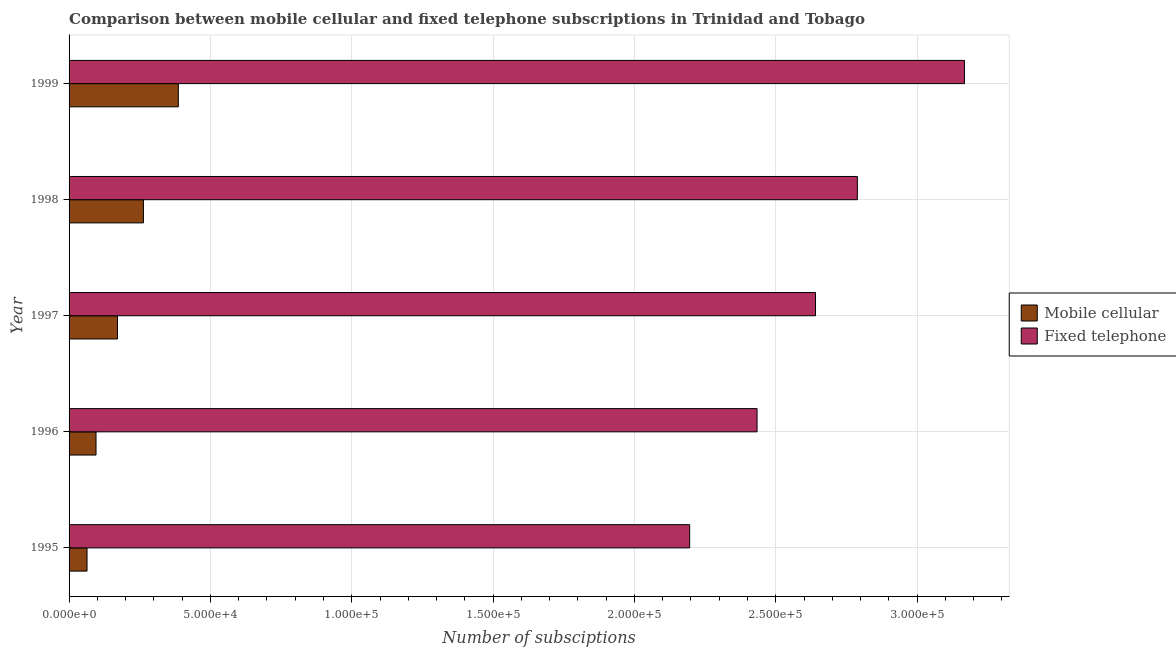How many different coloured bars are there?
Give a very brief answer. 2. How many groups of bars are there?
Your answer should be very brief. 5. How many bars are there on the 5th tick from the top?
Give a very brief answer. 2. How many bars are there on the 1st tick from the bottom?
Your answer should be compact. 2. What is the label of the 5th group of bars from the top?
Provide a short and direct response. 1995. What is the number of fixed telephone subscriptions in 1996?
Provide a succinct answer. 2.43e+05. Across all years, what is the maximum number of fixed telephone subscriptions?
Your response must be concise. 3.17e+05. Across all years, what is the minimum number of fixed telephone subscriptions?
Your answer should be compact. 2.20e+05. In which year was the number of fixed telephone subscriptions maximum?
Offer a terse response. 1999. In which year was the number of mobile cellular subscriptions minimum?
Keep it short and to the point. 1995. What is the total number of fixed telephone subscriptions in the graph?
Offer a very short reply. 1.32e+06. What is the difference between the number of fixed telephone subscriptions in 1996 and that in 1998?
Give a very brief answer. -3.55e+04. What is the difference between the number of mobile cellular subscriptions in 1995 and the number of fixed telephone subscriptions in 1996?
Ensure brevity in your answer.  -2.37e+05. What is the average number of mobile cellular subscriptions per year?
Ensure brevity in your answer.  1.96e+04. In the year 1997, what is the difference between the number of mobile cellular subscriptions and number of fixed telephone subscriptions?
Give a very brief answer. -2.47e+05. What is the ratio of the number of fixed telephone subscriptions in 1996 to that in 1999?
Your response must be concise. 0.77. Is the difference between the number of mobile cellular subscriptions in 1995 and 1998 greater than the difference between the number of fixed telephone subscriptions in 1995 and 1998?
Offer a very short reply. Yes. What is the difference between the highest and the second highest number of mobile cellular subscriptions?
Keep it short and to the point. 1.24e+04. What is the difference between the highest and the lowest number of mobile cellular subscriptions?
Offer a terse response. 3.23e+04. What does the 2nd bar from the top in 1995 represents?
Your response must be concise. Mobile cellular. What does the 2nd bar from the bottom in 1997 represents?
Your answer should be very brief. Fixed telephone. How many years are there in the graph?
Ensure brevity in your answer.  5. What is the difference between two consecutive major ticks on the X-axis?
Keep it short and to the point. 5.00e+04. How many legend labels are there?
Your answer should be compact. 2. How are the legend labels stacked?
Offer a terse response. Vertical. What is the title of the graph?
Provide a succinct answer. Comparison between mobile cellular and fixed telephone subscriptions in Trinidad and Tobago. What is the label or title of the X-axis?
Make the answer very short. Number of subsciptions. What is the Number of subsciptions of Mobile cellular in 1995?
Provide a succinct answer. 6353. What is the Number of subsciptions in Fixed telephone in 1995?
Offer a terse response. 2.20e+05. What is the Number of subsciptions in Mobile cellular in 1996?
Keep it short and to the point. 9534. What is the Number of subsciptions of Fixed telephone in 1996?
Provide a short and direct response. 2.43e+05. What is the Number of subsciptions of Mobile cellular in 1997?
Your answer should be very brief. 1.71e+04. What is the Number of subsciptions of Fixed telephone in 1997?
Provide a succinct answer. 2.64e+05. What is the Number of subsciptions in Mobile cellular in 1998?
Ensure brevity in your answer.  2.63e+04. What is the Number of subsciptions of Fixed telephone in 1998?
Offer a terse response. 2.79e+05. What is the Number of subsciptions of Mobile cellular in 1999?
Offer a terse response. 3.87e+04. What is the Number of subsciptions of Fixed telephone in 1999?
Ensure brevity in your answer.  3.17e+05. Across all years, what is the maximum Number of subsciptions of Mobile cellular?
Offer a very short reply. 3.87e+04. Across all years, what is the maximum Number of subsciptions of Fixed telephone?
Provide a succinct answer. 3.17e+05. Across all years, what is the minimum Number of subsciptions in Mobile cellular?
Your response must be concise. 6353. Across all years, what is the minimum Number of subsciptions of Fixed telephone?
Keep it short and to the point. 2.20e+05. What is the total Number of subsciptions in Mobile cellular in the graph?
Your response must be concise. 9.80e+04. What is the total Number of subsciptions of Fixed telephone in the graph?
Provide a succinct answer. 1.32e+06. What is the difference between the Number of subsciptions in Mobile cellular in 1995 and that in 1996?
Ensure brevity in your answer.  -3181. What is the difference between the Number of subsciptions in Fixed telephone in 1995 and that in 1996?
Your answer should be compact. -2.38e+04. What is the difference between the Number of subsciptions of Mobile cellular in 1995 and that in 1997?
Provide a short and direct response. -1.08e+04. What is the difference between the Number of subsciptions of Fixed telephone in 1995 and that in 1997?
Offer a terse response. -4.45e+04. What is the difference between the Number of subsciptions of Mobile cellular in 1995 and that in 1998?
Offer a terse response. -2.00e+04. What is the difference between the Number of subsciptions in Fixed telephone in 1995 and that in 1998?
Give a very brief answer. -5.93e+04. What is the difference between the Number of subsciptions in Mobile cellular in 1995 and that in 1999?
Give a very brief answer. -3.23e+04. What is the difference between the Number of subsciptions in Fixed telephone in 1995 and that in 1999?
Your response must be concise. -9.72e+04. What is the difference between the Number of subsciptions in Mobile cellular in 1996 and that in 1997?
Your response must be concise. -7606. What is the difference between the Number of subsciptions in Fixed telephone in 1996 and that in 1997?
Give a very brief answer. -2.07e+04. What is the difference between the Number of subsciptions in Mobile cellular in 1996 and that in 1998?
Offer a terse response. -1.68e+04. What is the difference between the Number of subsciptions of Fixed telephone in 1996 and that in 1998?
Provide a short and direct response. -3.55e+04. What is the difference between the Number of subsciptions in Mobile cellular in 1996 and that in 1999?
Offer a very short reply. -2.91e+04. What is the difference between the Number of subsciptions in Fixed telephone in 1996 and that in 1999?
Provide a succinct answer. -7.34e+04. What is the difference between the Number of subsciptions in Mobile cellular in 1997 and that in 1998?
Your answer should be compact. -9167. What is the difference between the Number of subsciptions in Fixed telephone in 1997 and that in 1998?
Provide a short and direct response. -1.48e+04. What is the difference between the Number of subsciptions of Mobile cellular in 1997 and that in 1999?
Offer a very short reply. -2.15e+04. What is the difference between the Number of subsciptions in Fixed telephone in 1997 and that in 1999?
Give a very brief answer. -5.27e+04. What is the difference between the Number of subsciptions in Mobile cellular in 1998 and that in 1999?
Offer a very short reply. -1.24e+04. What is the difference between the Number of subsciptions of Fixed telephone in 1998 and that in 1999?
Ensure brevity in your answer.  -3.79e+04. What is the difference between the Number of subsciptions in Mobile cellular in 1995 and the Number of subsciptions in Fixed telephone in 1996?
Make the answer very short. -2.37e+05. What is the difference between the Number of subsciptions of Mobile cellular in 1995 and the Number of subsciptions of Fixed telephone in 1997?
Offer a terse response. -2.58e+05. What is the difference between the Number of subsciptions in Mobile cellular in 1995 and the Number of subsciptions in Fixed telephone in 1998?
Give a very brief answer. -2.73e+05. What is the difference between the Number of subsciptions in Mobile cellular in 1995 and the Number of subsciptions in Fixed telephone in 1999?
Offer a terse response. -3.10e+05. What is the difference between the Number of subsciptions in Mobile cellular in 1996 and the Number of subsciptions in Fixed telephone in 1997?
Offer a very short reply. -2.55e+05. What is the difference between the Number of subsciptions in Mobile cellular in 1996 and the Number of subsciptions in Fixed telephone in 1998?
Offer a very short reply. -2.69e+05. What is the difference between the Number of subsciptions in Mobile cellular in 1996 and the Number of subsciptions in Fixed telephone in 1999?
Provide a succinct answer. -3.07e+05. What is the difference between the Number of subsciptions of Mobile cellular in 1997 and the Number of subsciptions of Fixed telephone in 1998?
Give a very brief answer. -2.62e+05. What is the difference between the Number of subsciptions of Mobile cellular in 1997 and the Number of subsciptions of Fixed telephone in 1999?
Your answer should be very brief. -3.00e+05. What is the difference between the Number of subsciptions of Mobile cellular in 1998 and the Number of subsciptions of Fixed telephone in 1999?
Your response must be concise. -2.90e+05. What is the average Number of subsciptions in Mobile cellular per year?
Ensure brevity in your answer.  1.96e+04. What is the average Number of subsciptions in Fixed telephone per year?
Provide a short and direct response. 2.65e+05. In the year 1995, what is the difference between the Number of subsciptions in Mobile cellular and Number of subsciptions in Fixed telephone?
Your answer should be compact. -2.13e+05. In the year 1996, what is the difference between the Number of subsciptions of Mobile cellular and Number of subsciptions of Fixed telephone?
Your answer should be compact. -2.34e+05. In the year 1997, what is the difference between the Number of subsciptions of Mobile cellular and Number of subsciptions of Fixed telephone?
Your response must be concise. -2.47e+05. In the year 1998, what is the difference between the Number of subsciptions in Mobile cellular and Number of subsciptions in Fixed telephone?
Offer a terse response. -2.53e+05. In the year 1999, what is the difference between the Number of subsciptions in Mobile cellular and Number of subsciptions in Fixed telephone?
Your answer should be compact. -2.78e+05. What is the ratio of the Number of subsciptions in Mobile cellular in 1995 to that in 1996?
Your answer should be very brief. 0.67. What is the ratio of the Number of subsciptions of Fixed telephone in 1995 to that in 1996?
Your response must be concise. 0.9. What is the ratio of the Number of subsciptions of Mobile cellular in 1995 to that in 1997?
Give a very brief answer. 0.37. What is the ratio of the Number of subsciptions in Fixed telephone in 1995 to that in 1997?
Your answer should be very brief. 0.83. What is the ratio of the Number of subsciptions in Mobile cellular in 1995 to that in 1998?
Provide a short and direct response. 0.24. What is the ratio of the Number of subsciptions in Fixed telephone in 1995 to that in 1998?
Provide a short and direct response. 0.79. What is the ratio of the Number of subsciptions in Mobile cellular in 1995 to that in 1999?
Ensure brevity in your answer.  0.16. What is the ratio of the Number of subsciptions of Fixed telephone in 1995 to that in 1999?
Keep it short and to the point. 0.69. What is the ratio of the Number of subsciptions in Mobile cellular in 1996 to that in 1997?
Give a very brief answer. 0.56. What is the ratio of the Number of subsciptions of Fixed telephone in 1996 to that in 1997?
Your answer should be compact. 0.92. What is the ratio of the Number of subsciptions of Mobile cellular in 1996 to that in 1998?
Offer a terse response. 0.36. What is the ratio of the Number of subsciptions in Fixed telephone in 1996 to that in 1998?
Your answer should be compact. 0.87. What is the ratio of the Number of subsciptions in Mobile cellular in 1996 to that in 1999?
Your answer should be very brief. 0.25. What is the ratio of the Number of subsciptions of Fixed telephone in 1996 to that in 1999?
Make the answer very short. 0.77. What is the ratio of the Number of subsciptions of Mobile cellular in 1997 to that in 1998?
Give a very brief answer. 0.65. What is the ratio of the Number of subsciptions of Fixed telephone in 1997 to that in 1998?
Give a very brief answer. 0.95. What is the ratio of the Number of subsciptions in Mobile cellular in 1997 to that in 1999?
Ensure brevity in your answer.  0.44. What is the ratio of the Number of subsciptions in Fixed telephone in 1997 to that in 1999?
Your response must be concise. 0.83. What is the ratio of the Number of subsciptions in Mobile cellular in 1998 to that in 1999?
Provide a succinct answer. 0.68. What is the ratio of the Number of subsciptions in Fixed telephone in 1998 to that in 1999?
Your response must be concise. 0.88. What is the difference between the highest and the second highest Number of subsciptions of Mobile cellular?
Keep it short and to the point. 1.24e+04. What is the difference between the highest and the second highest Number of subsciptions of Fixed telephone?
Make the answer very short. 3.79e+04. What is the difference between the highest and the lowest Number of subsciptions of Mobile cellular?
Make the answer very short. 3.23e+04. What is the difference between the highest and the lowest Number of subsciptions of Fixed telephone?
Give a very brief answer. 9.72e+04. 